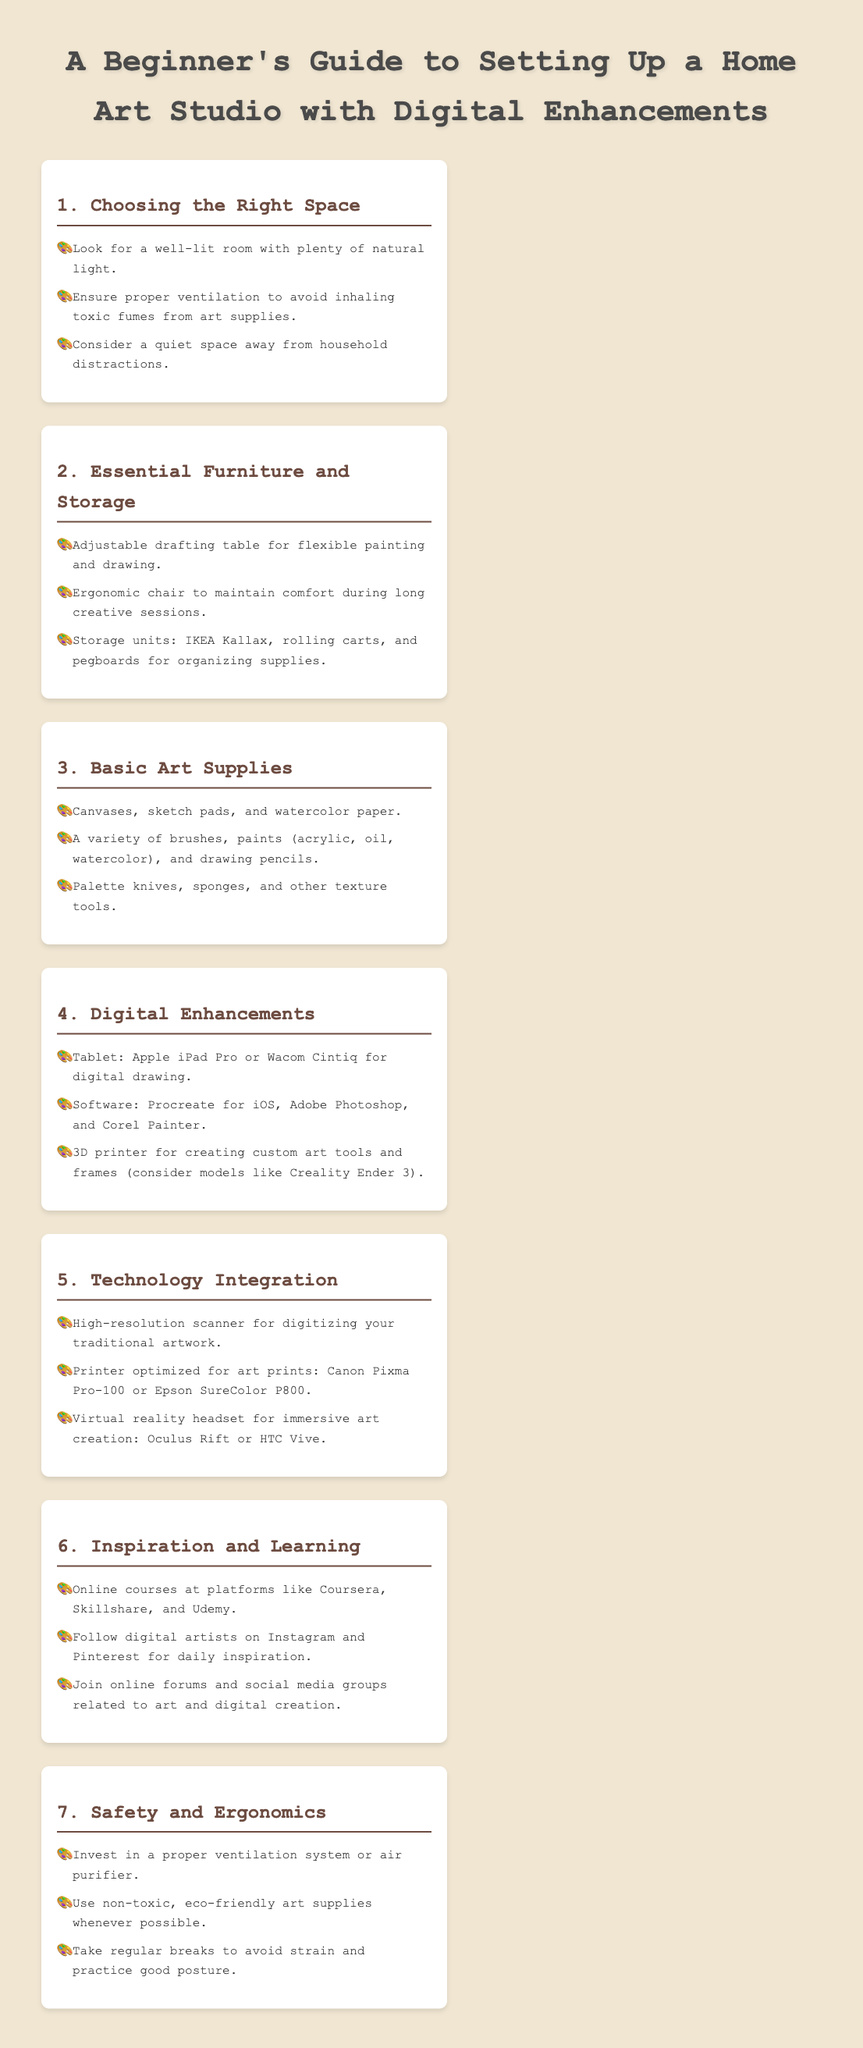What should you look for when choosing a space? Information about space selection can be found in Section 1, where it mentions criteria like natural light, ventilation, and distractions.
Answer: Natural light What type of table is recommended for an art studio? Section 2 discusses furniture and suggests an adjustable drafting table specifically for painting and drawing.
Answer: Adjustable drafting table Which software is suggested for digital drawing? Information about digital drawing tools and software is found in Section 4, which lists specific programs for artistic creation.
Answer: Procreate What equipment is advised for safety in your art studio? Section 7 highlights the importance of investing in a proper ventilation system or air purifier for safety in the studio.
Answer: Ventilation system What can help you learn new art techniques? Section 6 provides various resources for inspiration and learning, specifically mentioning online course platforms.
Answer: Online courses 